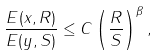Convert formula to latex. <formula><loc_0><loc_0><loc_500><loc_500>\frac { E ( x , R ) } { E ( y , S ) } \leq C \left ( \frac { R } { S } \right ) ^ { \beta } ,</formula> 